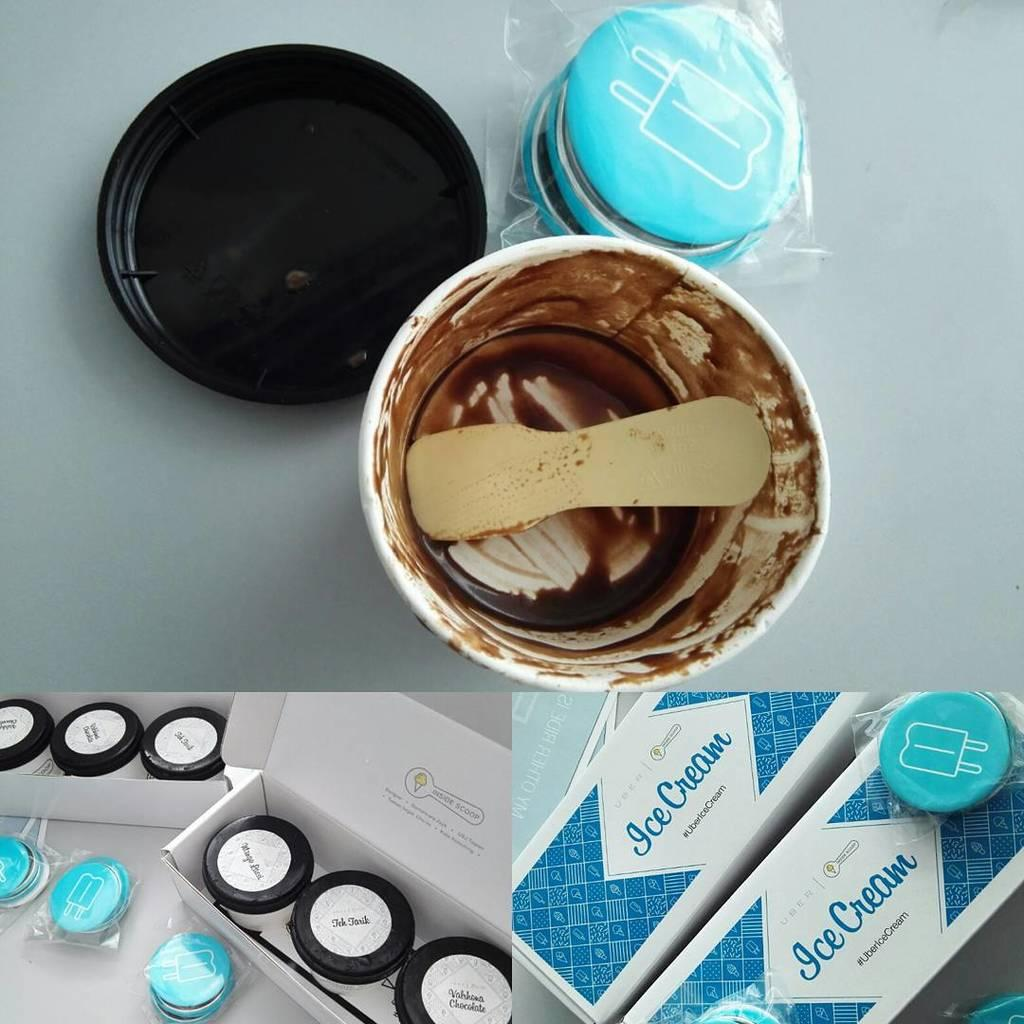<image>
Write a terse but informative summary of the picture. an image of icecream with an empty tub in the middle. 